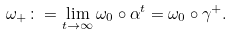<formula> <loc_0><loc_0><loc_500><loc_500>\omega _ { + } \colon = \lim _ { t \rightarrow \infty } \omega _ { 0 } \circ \alpha ^ { t } = \omega _ { 0 } \circ \gamma ^ { + } .</formula> 